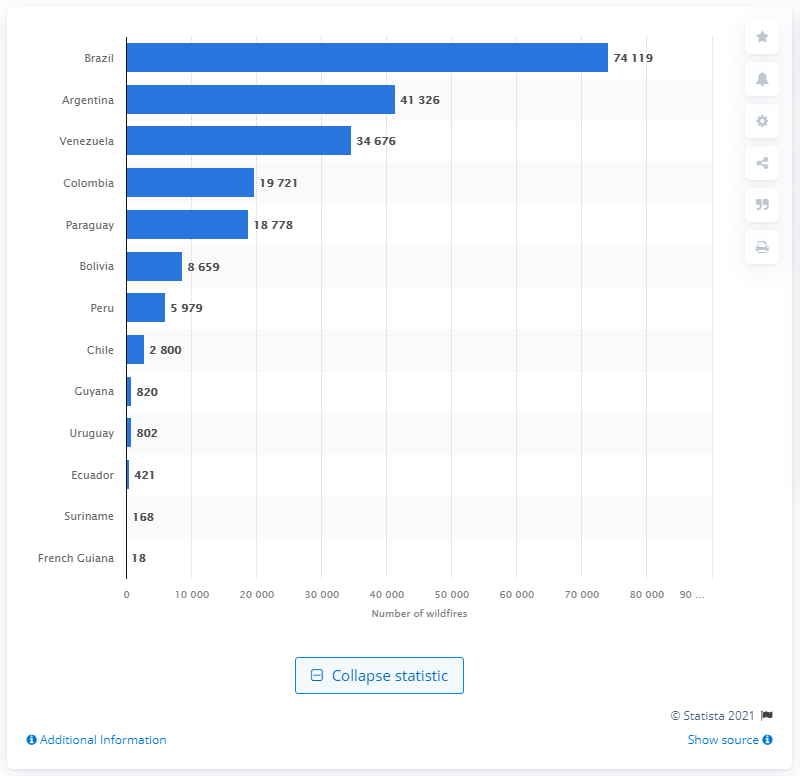Identify some key points in this picture. Argentina had the second largest number of wildfires. During the period of January 1st to August 20th of 2020, a total of 74,119 wildfires were reported in Brazil. A total of 18 wildfires were detected in French Guiana during the given period. 